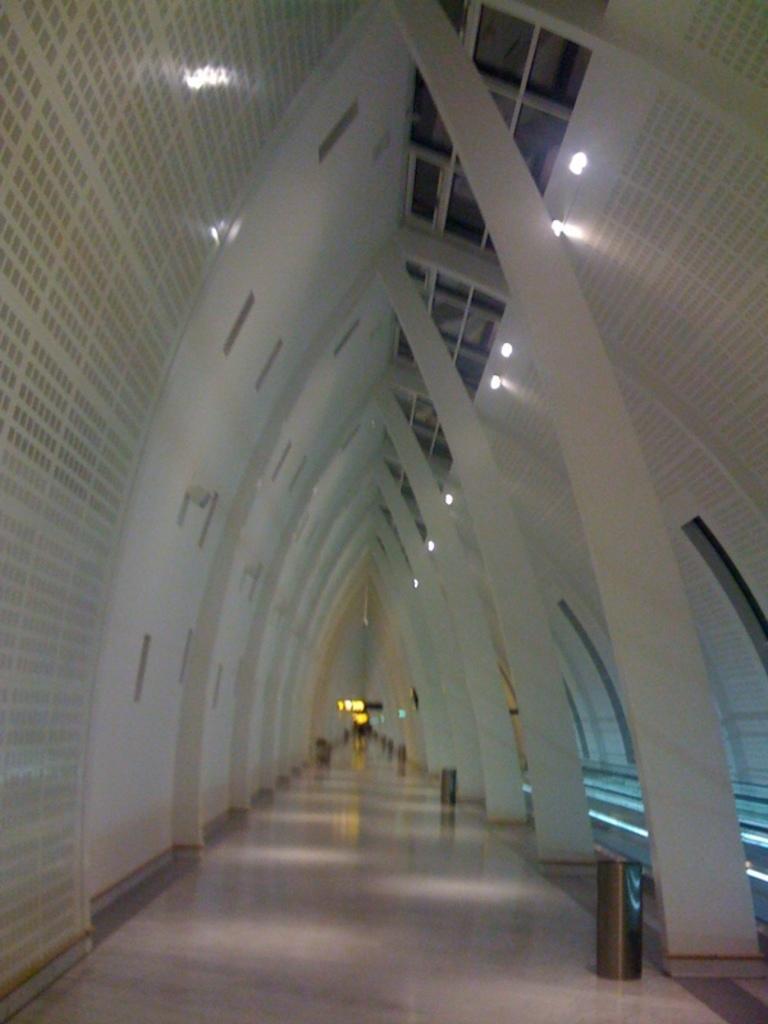In one or two sentences, can you explain what this image depicts? This is clicked inside a building, there is a v shaped ceiling wall with lights on it, there are dustbins on the floor with a path in the middle. 